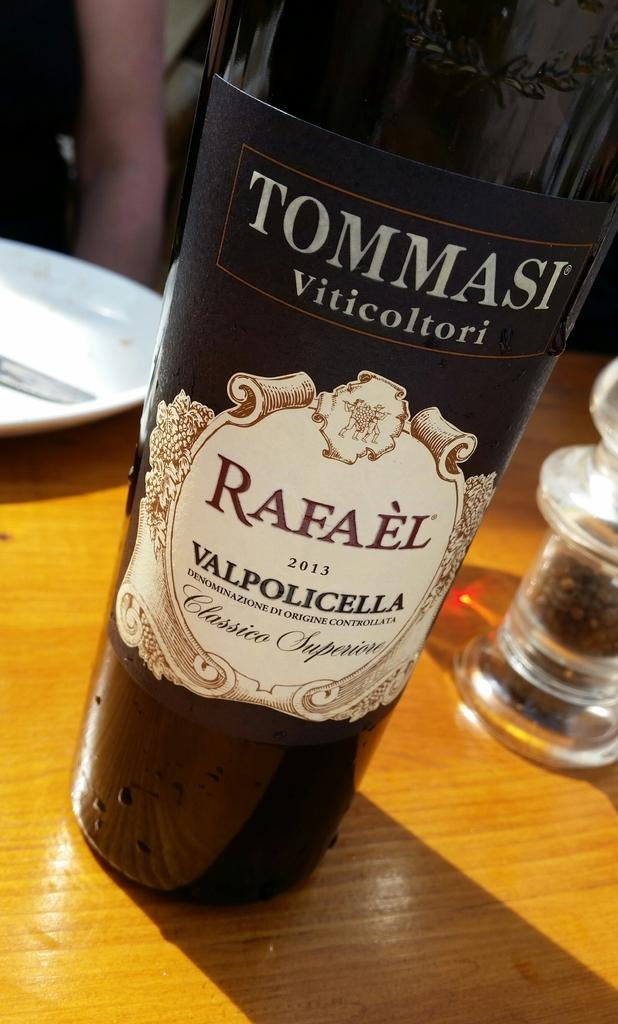<image>
Offer a succinct explanation of the picture presented. A bottle with Tommasi viticoltori and Rafeal on the label sits on a wooden table. 